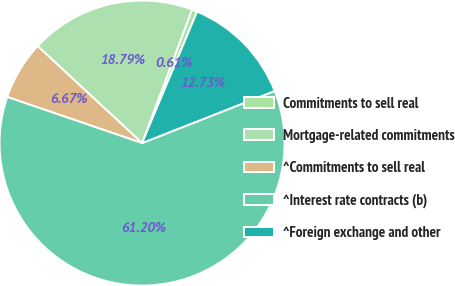Convert chart. <chart><loc_0><loc_0><loc_500><loc_500><pie_chart><fcel>Commitments to sell real<fcel>Mortgage-related commitments<fcel>^Commitments to sell real<fcel>^Interest rate contracts (b)<fcel>^Foreign exchange and other<nl><fcel>0.61%<fcel>18.79%<fcel>6.67%<fcel>61.21%<fcel>12.73%<nl></chart> 